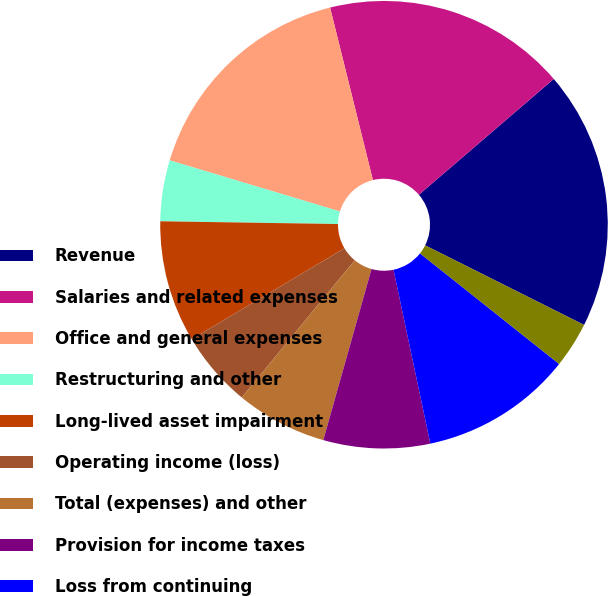Convert chart. <chart><loc_0><loc_0><loc_500><loc_500><pie_chart><fcel>Revenue<fcel>Salaries and related expenses<fcel>Office and general expenses<fcel>Restructuring and other<fcel>Long-lived asset impairment<fcel>Operating income (loss)<fcel>Total (expenses) and other<fcel>Provision for income taxes<fcel>Loss from continuing<fcel>Income from discontinued<nl><fcel>18.68%<fcel>17.58%<fcel>16.48%<fcel>4.4%<fcel>8.79%<fcel>5.49%<fcel>6.59%<fcel>7.69%<fcel>10.99%<fcel>3.3%<nl></chart> 